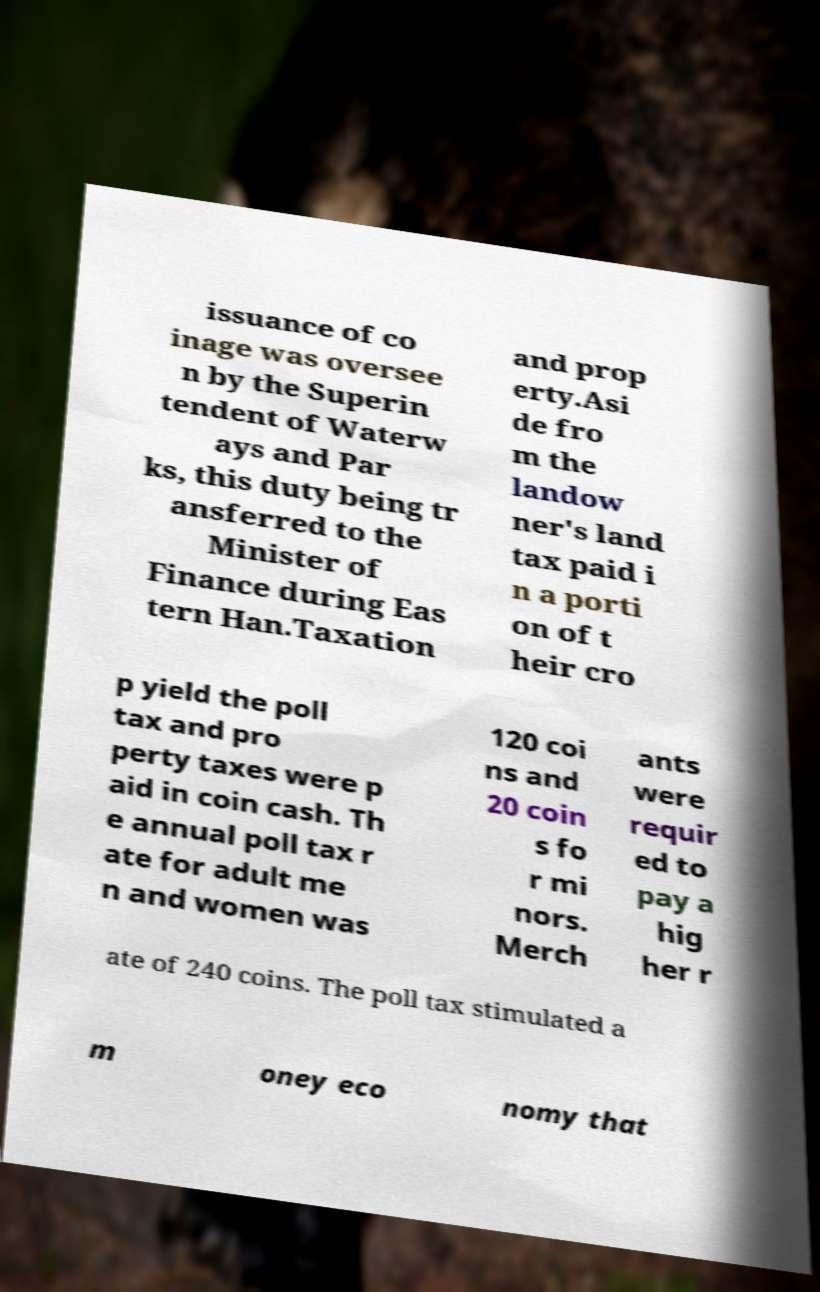Please identify and transcribe the text found in this image. issuance of co inage was oversee n by the Superin tendent of Waterw ays and Par ks, this duty being tr ansferred to the Minister of Finance during Eas tern Han.Taxation and prop erty.Asi de fro m the landow ner's land tax paid i n a porti on of t heir cro p yield the poll tax and pro perty taxes were p aid in coin cash. Th e annual poll tax r ate for adult me n and women was 120 coi ns and 20 coin s fo r mi nors. Merch ants were requir ed to pay a hig her r ate of 240 coins. The poll tax stimulated a m oney eco nomy that 